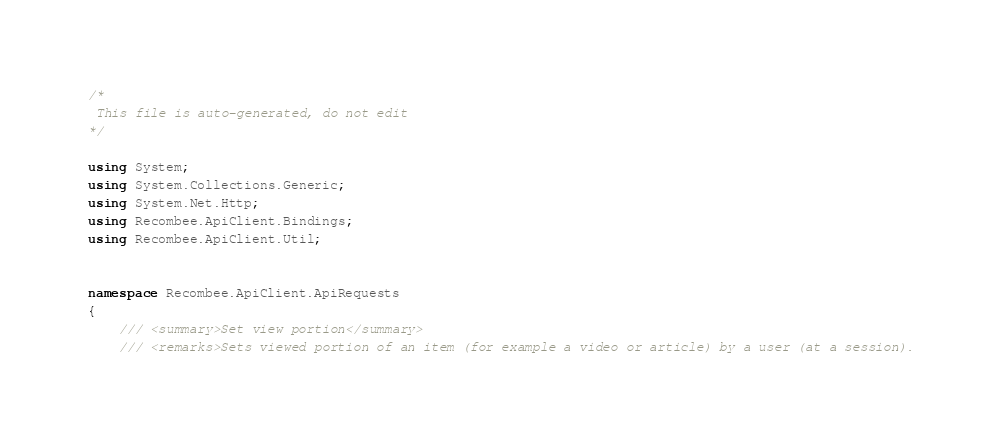<code> <loc_0><loc_0><loc_500><loc_500><_C#_>/*
 This file is auto-generated, do not edit
*/

using System;
using System.Collections.Generic;
using System.Net.Http;
using Recombee.ApiClient.Bindings;
using Recombee.ApiClient.Util;


namespace Recombee.ApiClient.ApiRequests
{
    /// <summary>Set view portion</summary>
    /// <remarks>Sets viewed portion of an item (for example a video or article) by a user (at a session).</code> 